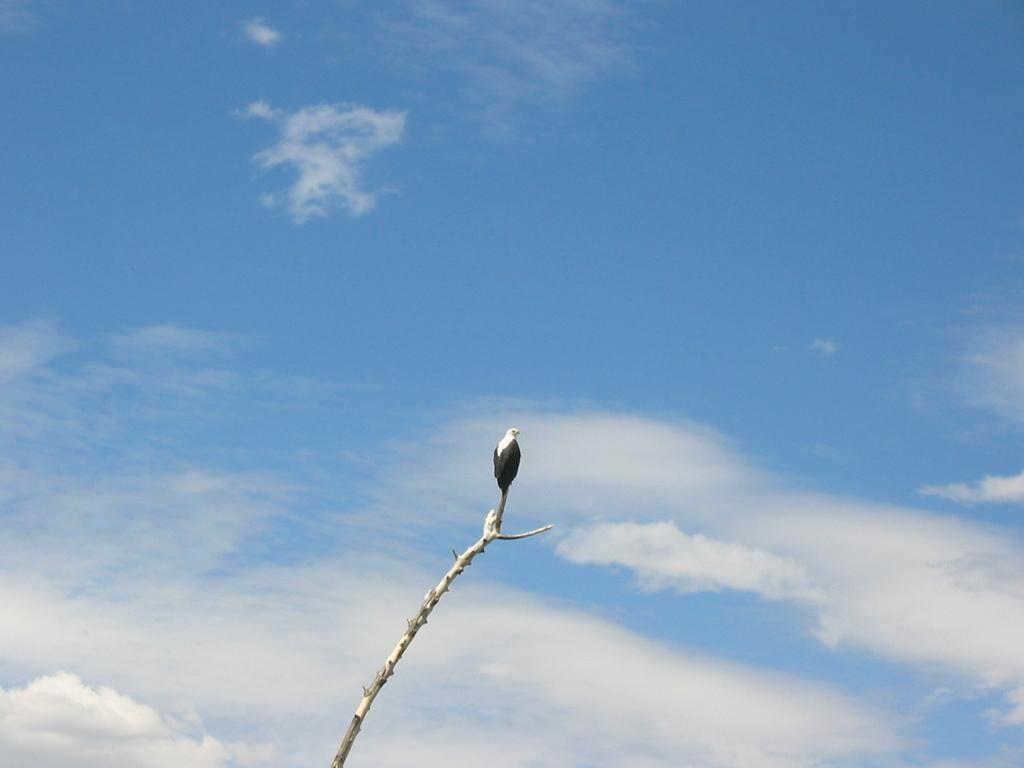What can be seen at the top of the image? There is a sky in the image. What is the main object in the image? There is a stem in the image, and the top of the stem is visible. What is positioned on the stem? There is an animal standing on the stem. Is the animal wearing shoes while standing on the stem in the image? There is no mention of shoes or any footwear in the image, so it cannot be determined if the animal is wearing shoes. 